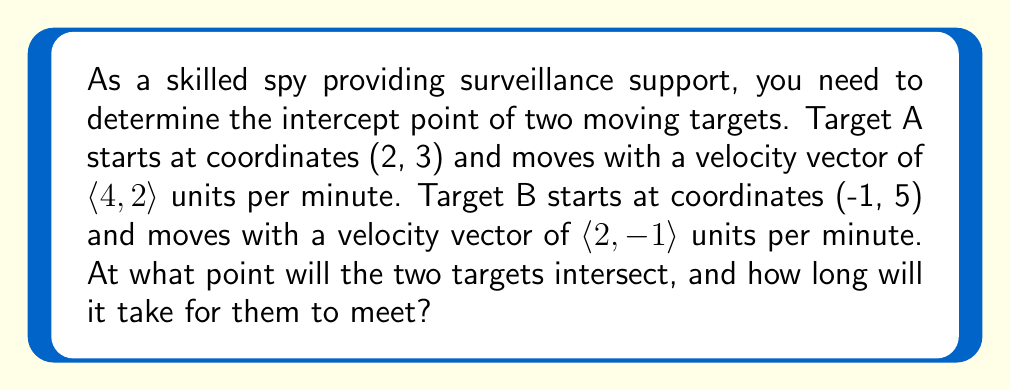Can you answer this question? To solve this problem, we need to use linear equations to represent the paths of both targets and find their intersection point.

1. Let's define the position of each target as a function of time t:

   Target A: $A(t) = (2+4t, 3+2t)$
   Target B: $B(t) = (-1+2t, 5-t)$

2. For the targets to intersect, their x and y coordinates must be equal at some time t:

   $2+4t = -1+2t$
   $3+2t = 5-t$

3. Let's solve the first equation for t:
   
   $2+4t = -1+2t$
   $4t - 2t = -1-2$
   $2t = -3$
   $t = -\frac{3}{2}$

4. Now, let's verify if this t satisfies the second equation:

   $3+2(-\frac{3}{2}) = 5-(-\frac{3}{2})$
   $3-3 = 5+\frac{3}{2}$
   $0 = \frac{13}{2}$

   This is not true, so we need to solve the system of equations.

5. Let's rewrite our system:

   $4t - 2t = -3$
   $2t + t = 2$

   Adding these equations:

   $5t = -1$
   $t = -\frac{1}{5}$

6. Now that we have t, we can find the intersection point by substituting t into either target's equation:

   $A(-\frac{1}{5}) = (2+4(-\frac{1}{5}), 3+2(-\frac{1}{5}))$
                    $= (2-\frac{4}{5}, 3-\frac{2}{5})$
                    $= (\frac{6}{5}, \frac{13}{5})$

   We can verify this with Target B's equation:

   $B(-\frac{1}{5}) = (-1+2(-\frac{1}{5}), 5-(-\frac{1}{5}))$
                    $= (-1-\frac{2}{5}, 5+\frac{1}{5})$
                    $= (\frac{-7}{5}+\frac{13}{5}, \frac{26}{5}-\frac{13}{5})$
                    $= (\frac{6}{5}, \frac{13}{5})$
Answer: The targets will intersect at the point $(\frac{6}{5}, \frac{13}{5})$ or $(1.2, 2.6)$ after $\frac{1}{5}$ minutes (or 12 seconds). 